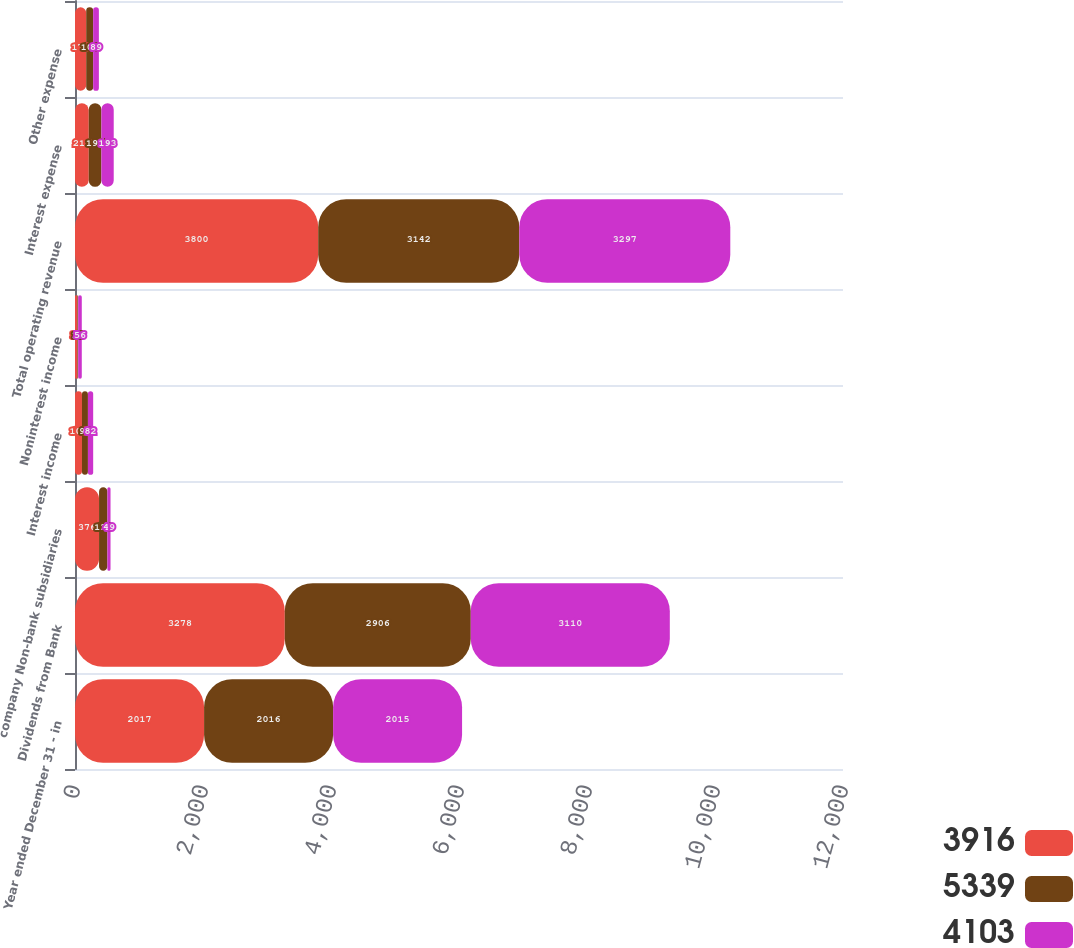Convert chart to OTSL. <chart><loc_0><loc_0><loc_500><loc_500><stacked_bar_chart><ecel><fcel>Year ended December 31 - in<fcel>Dividends from Bank<fcel>company Non-bank subsidiaries<fcel>Interest income<fcel>Noninterest income<fcel>Total operating revenue<fcel>Interest expense<fcel>Other expense<nl><fcel>3916<fcel>2017<fcel>3278<fcel>376<fcel>109<fcel>37<fcel>3800<fcel>215<fcel>175<nl><fcel>5339<fcel>2016<fcel>2906<fcel>130<fcel>93<fcel>13<fcel>3142<fcel>197<fcel>109<nl><fcel>4103<fcel>2015<fcel>3110<fcel>49<fcel>82<fcel>56<fcel>3297<fcel>193<fcel>89<nl></chart> 